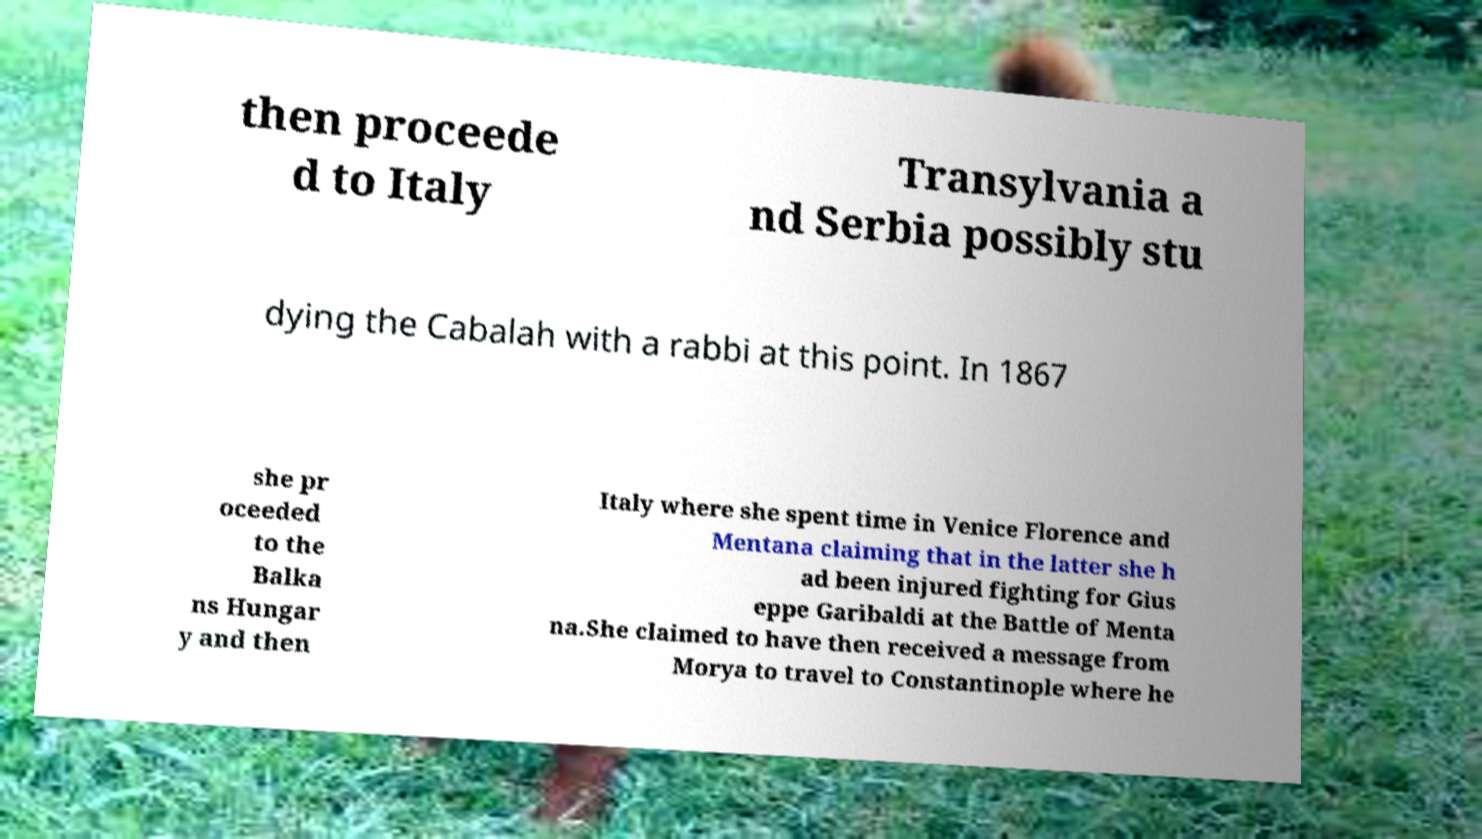For documentation purposes, I need the text within this image transcribed. Could you provide that? then proceede d to Italy Transylvania a nd Serbia possibly stu dying the Cabalah with a rabbi at this point. In 1867 she pr oceeded to the Balka ns Hungar y and then Italy where she spent time in Venice Florence and Mentana claiming that in the latter she h ad been injured fighting for Gius eppe Garibaldi at the Battle of Menta na.She claimed to have then received a message from Morya to travel to Constantinople where he 